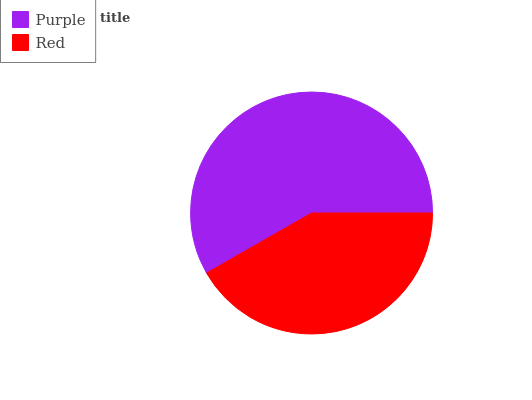Is Red the minimum?
Answer yes or no. Yes. Is Purple the maximum?
Answer yes or no. Yes. Is Red the maximum?
Answer yes or no. No. Is Purple greater than Red?
Answer yes or no. Yes. Is Red less than Purple?
Answer yes or no. Yes. Is Red greater than Purple?
Answer yes or no. No. Is Purple less than Red?
Answer yes or no. No. Is Purple the high median?
Answer yes or no. Yes. Is Red the low median?
Answer yes or no. Yes. Is Red the high median?
Answer yes or no. No. Is Purple the low median?
Answer yes or no. No. 